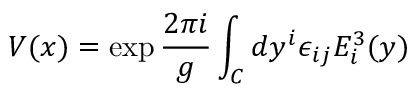<formula> <loc_0><loc_0><loc_500><loc_500>V ( x ) = \exp { \frac { 2 \pi i } { g } } \int _ { C } d y ^ { i } \epsilon _ { i j } E _ { i } ^ { 3 } ( y )</formula> 